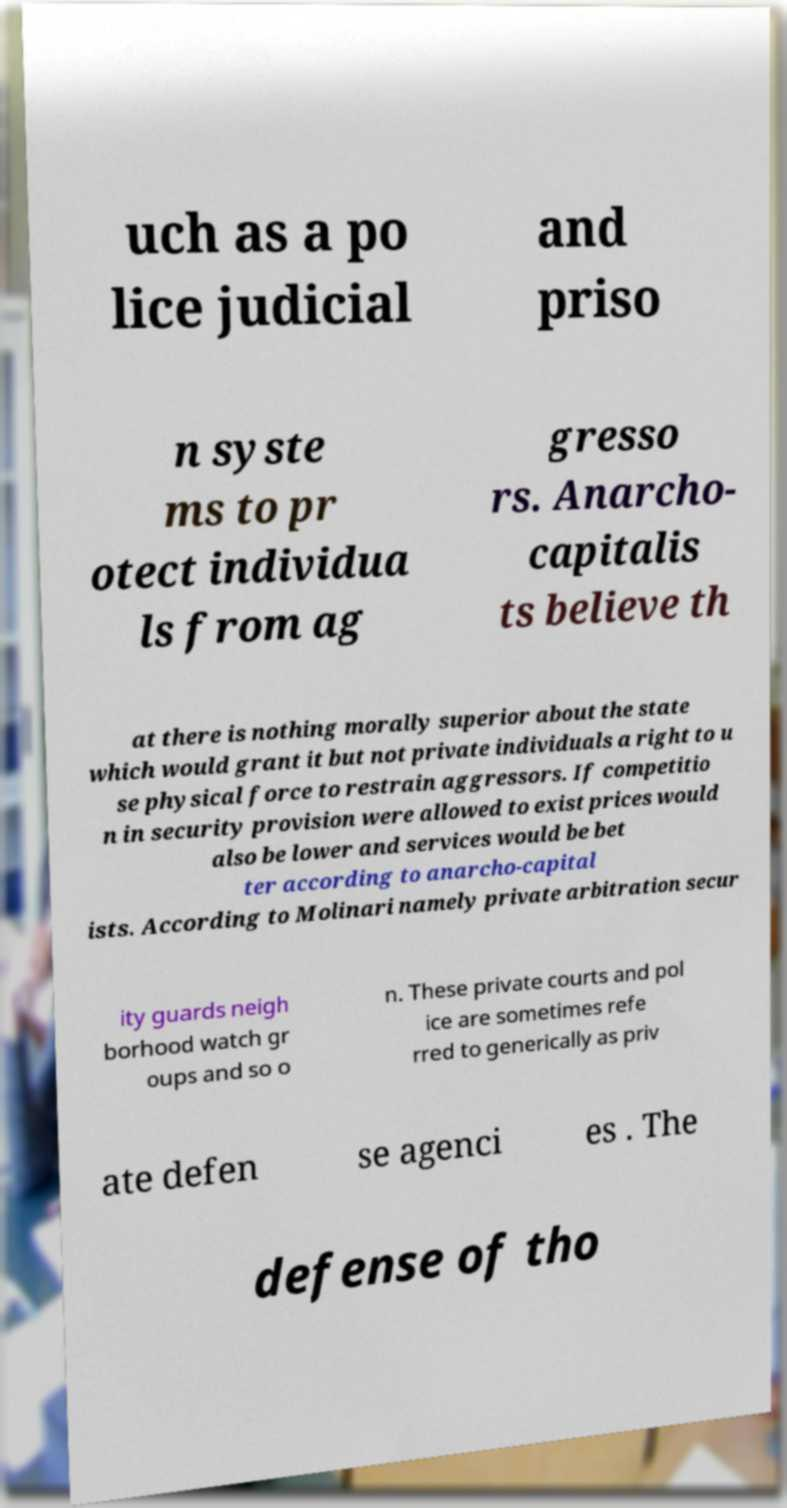Could you extract and type out the text from this image? uch as a po lice judicial and priso n syste ms to pr otect individua ls from ag gresso rs. Anarcho- capitalis ts believe th at there is nothing morally superior about the state which would grant it but not private individuals a right to u se physical force to restrain aggressors. If competitio n in security provision were allowed to exist prices would also be lower and services would be bet ter according to anarcho-capital ists. According to Molinari namely private arbitration secur ity guards neigh borhood watch gr oups and so o n. These private courts and pol ice are sometimes refe rred to generically as priv ate defen se agenci es . The defense of tho 